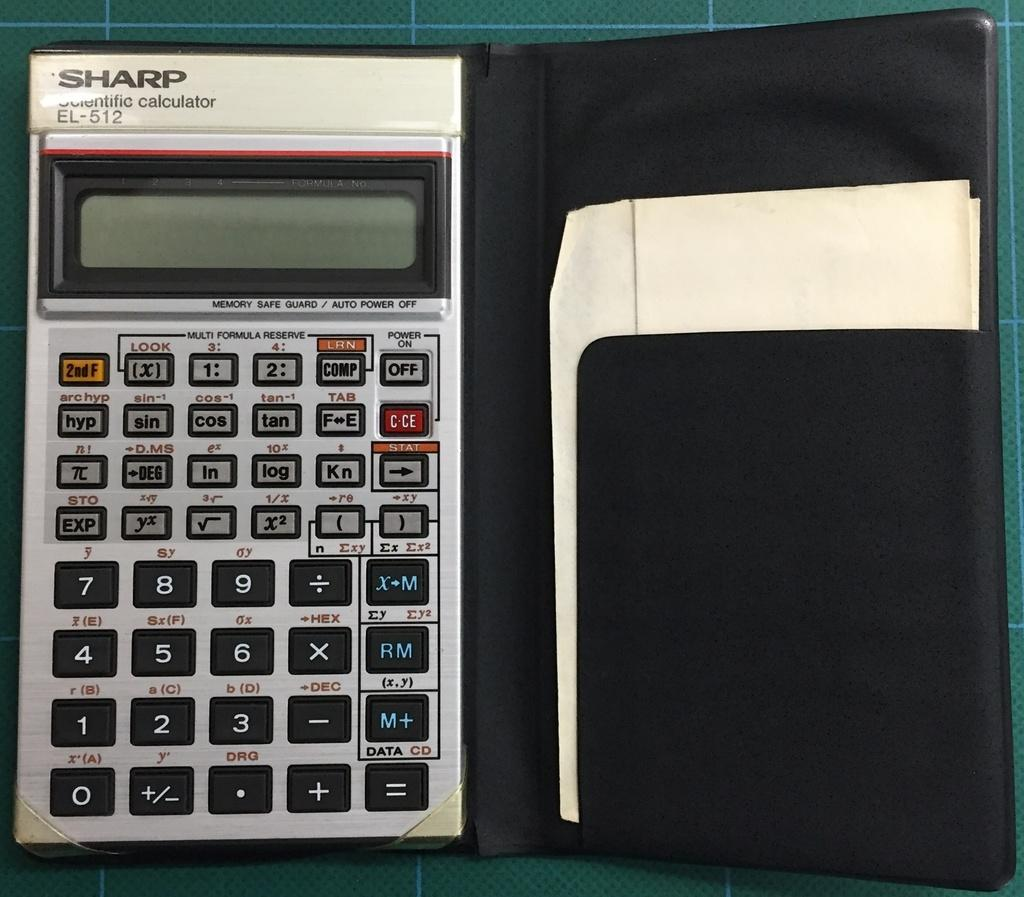<image>
Create a compact narrative representing the image presented. A Sharp scientific calculator that is in a protective case. 